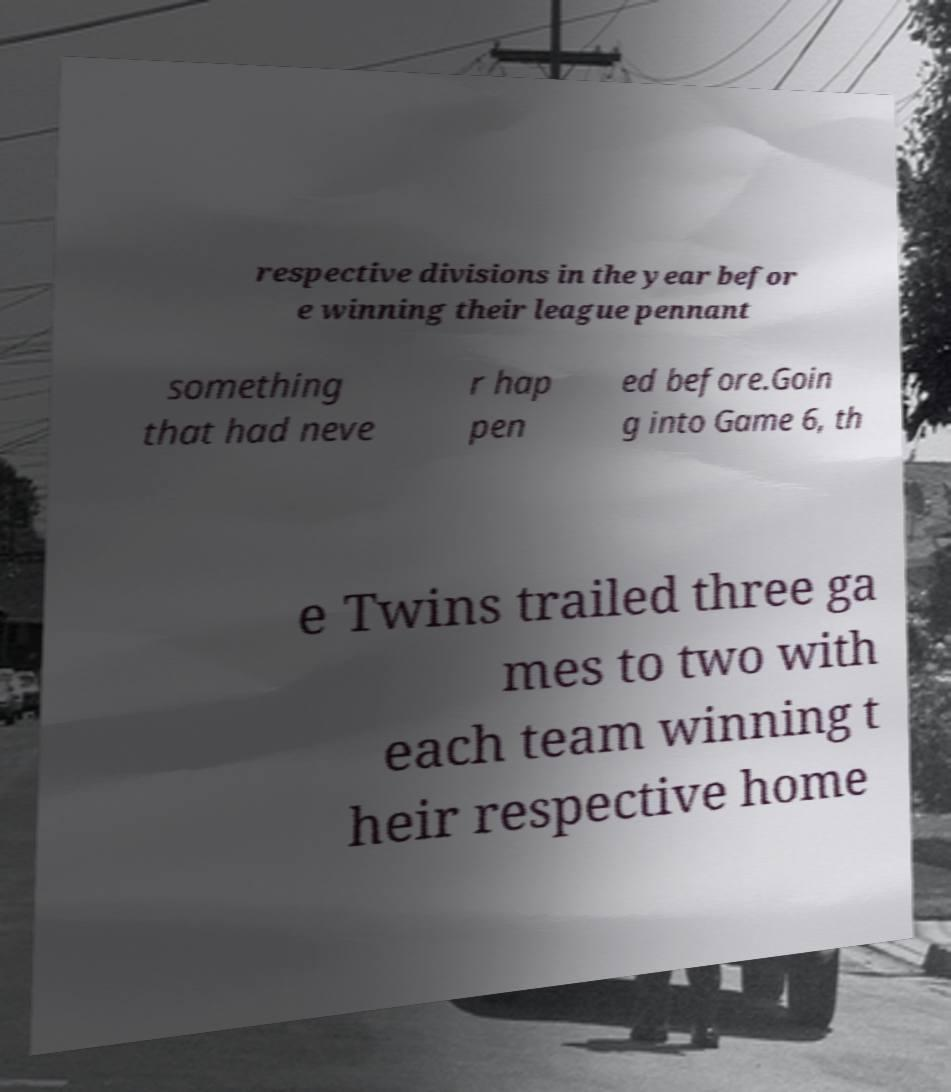Can you read and provide the text displayed in the image?This photo seems to have some interesting text. Can you extract and type it out for me? respective divisions in the year befor e winning their league pennant something that had neve r hap pen ed before.Goin g into Game 6, th e Twins trailed three ga mes to two with each team winning t heir respective home 